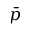<formula> <loc_0><loc_0><loc_500><loc_500>\bar { p }</formula> 